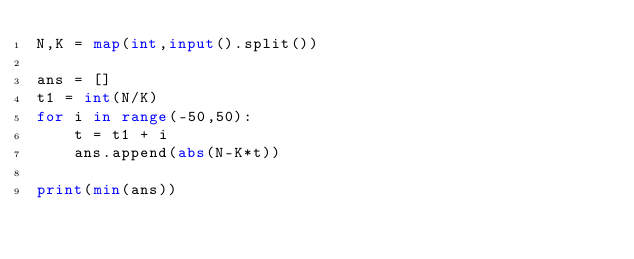Convert code to text. <code><loc_0><loc_0><loc_500><loc_500><_Python_>N,K = map(int,input().split())

ans = []
t1 = int(N/K)
for i in range(-50,50):
    t = t1 + i
    ans.append(abs(N-K*t))
    
print(min(ans))</code> 